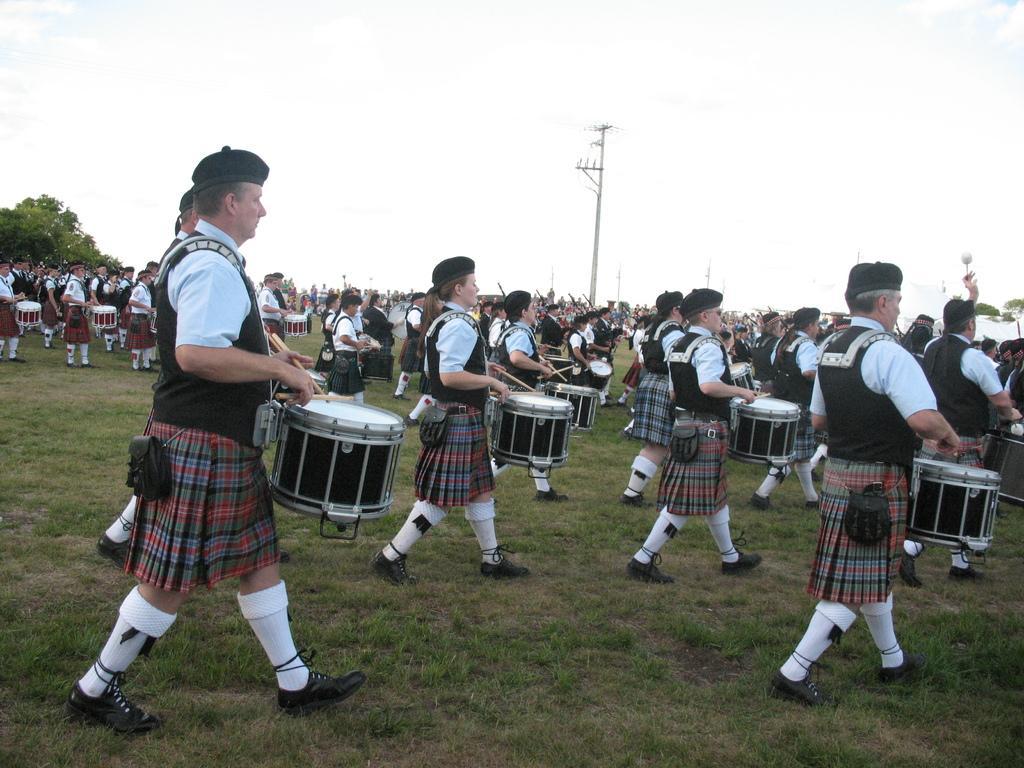Describe this image in one or two sentences. These people are walking and playing musical drums. Land is covered with grass. Background we can see the sky, pole and trees.  